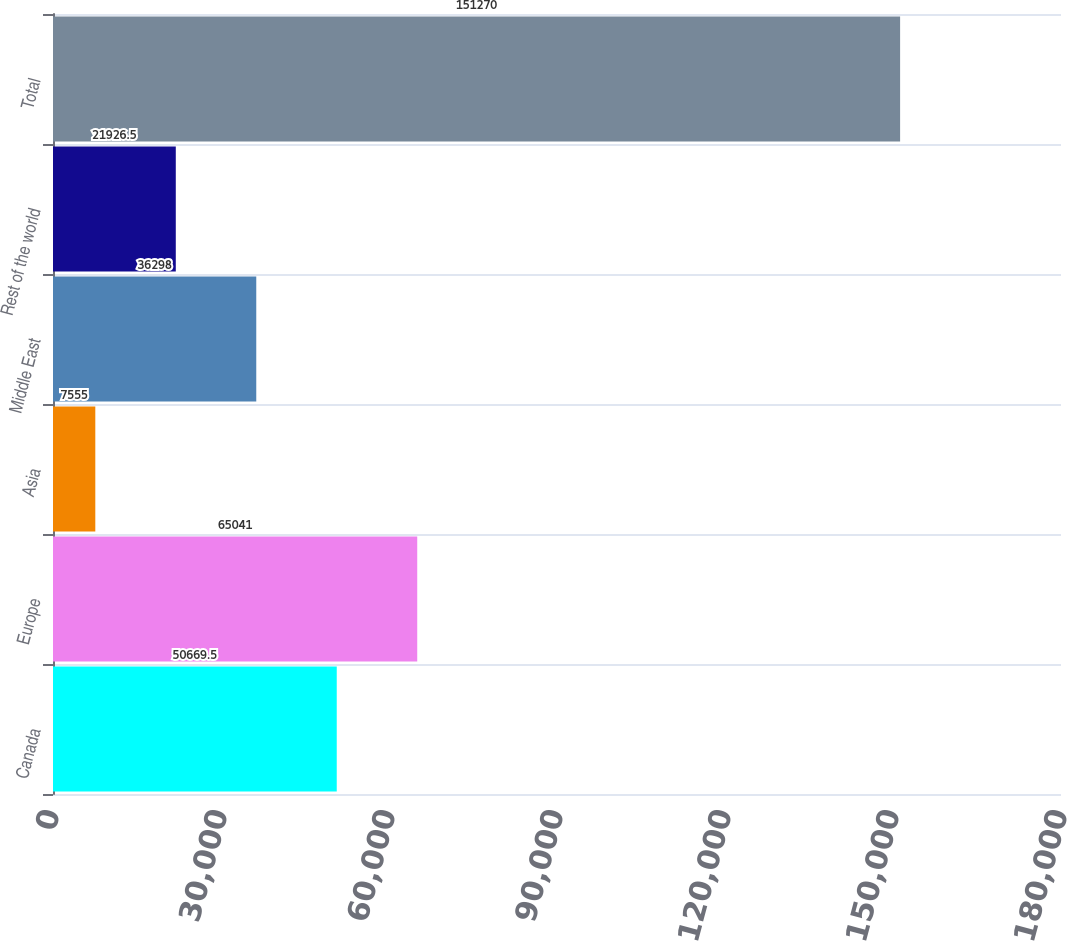Convert chart. <chart><loc_0><loc_0><loc_500><loc_500><bar_chart><fcel>Canada<fcel>Europe<fcel>Asia<fcel>Middle East<fcel>Rest of the world<fcel>Total<nl><fcel>50669.5<fcel>65041<fcel>7555<fcel>36298<fcel>21926.5<fcel>151270<nl></chart> 